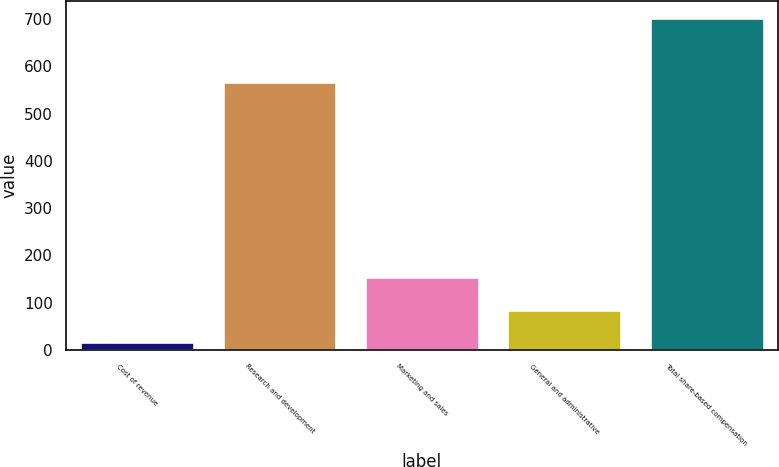Convert chart to OTSL. <chart><loc_0><loc_0><loc_500><loc_500><bar_chart><fcel>Cost of revenue<fcel>Research and development<fcel>Marketing and sales<fcel>General and administrative<fcel>Total share-based compensation<nl><fcel>17<fcel>566<fcel>154.2<fcel>85.6<fcel>703<nl></chart> 